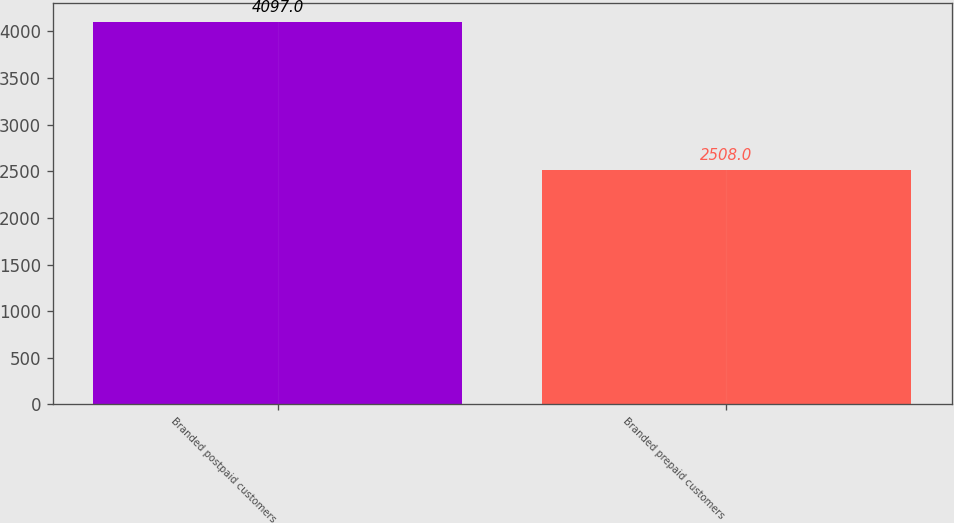Convert chart to OTSL. <chart><loc_0><loc_0><loc_500><loc_500><bar_chart><fcel>Branded postpaid customers<fcel>Branded prepaid customers<nl><fcel>4097<fcel>2508<nl></chart> 